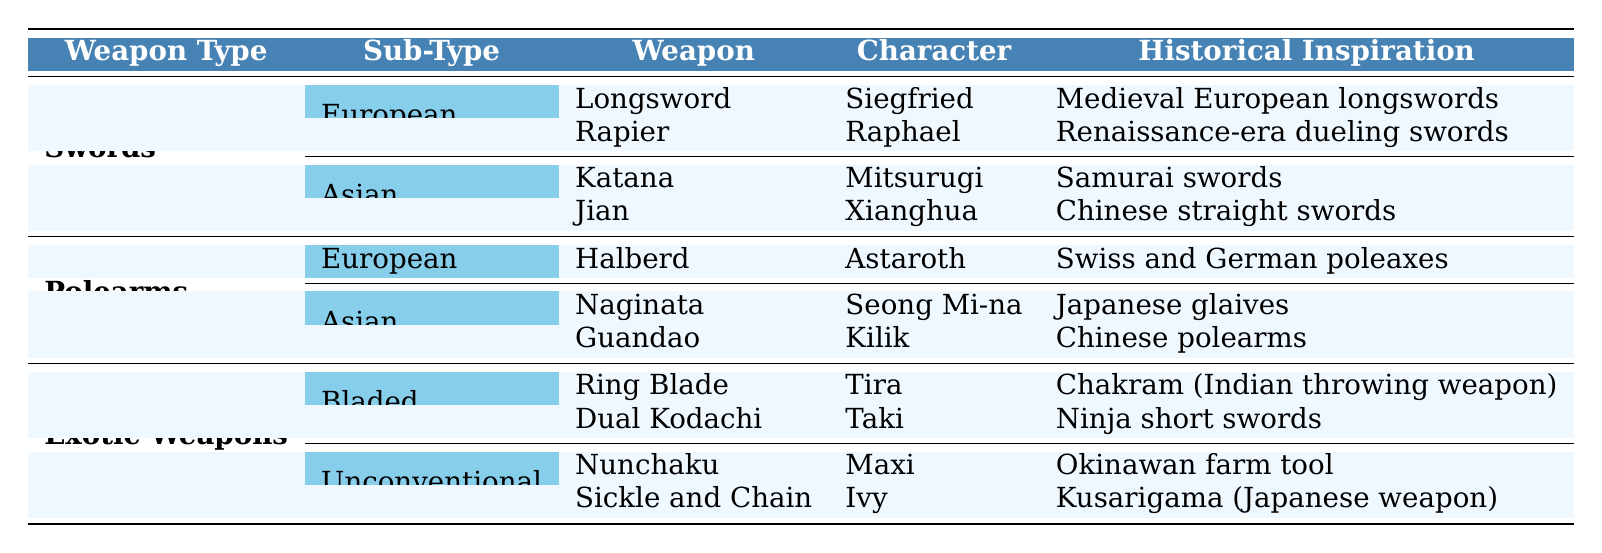What is the historical inspiration for the weapon used by Siegfried? By looking at the row that includes Siegfried, we can see that his weapon is the Longsword, and the historical inspiration listed for it is "Medieval European longswords."
Answer: Medieval European longswords How many different weapon types are represented in the table? The table lists three weapon types: Swords, Polearms, and Exotic Weapons. So, we count them up to get a total of three.
Answer: 3 Which weapon character is associated with the Guandao? By looking at the row corresponding to the Guandao, we find that the associated character is Kilik.
Answer: Kilik Are there any Asian weapons inspired by Chinese martial culture? Yes, the Jian and Guandao are both weapons in the Asian category that have direct historical inspirations from Chinese martial culture.
Answer: Yes Which character uses the Nunchaku, and what is its historical inspiration? From the table, we see that Maxi uses the Nunchaku, and its historical inspiration is an Okinawan farm tool.
Answer: Maxi, Okinawan farm tool What is the relationship between the character Taki and the weapon type "Exotic Weapons"? Taki uses the Dual Kodachi, which is classified under the "Exotic Weapons" category in the table. This shows that she is associated with an unconventional type of weapon.
Answer: Dual Kodachi Identify the weapon type with the most characters listed in the table. Evaluating the number of characters associated with each weapon type, Swords has four characters (Siegfried, Raphael, Mitsurugi, Xianghua), whereas Polearms has three (Astaroth, Seong Mi-na, Kilik), and Exotic Weapons has four (Tira, Taki, Maxi, Ivy). Hence, both Swords and Exotic Weapons tie for the most characters.
Answer: Swords and Exotic Weapons Which weapon is influenced by Japanese glaives and who wields it? Referring to the table, the weapon influenced by Japanese glaives is the Naginata, and it is wielded by Seong Mi-na.
Answer: Naginata, Seong Mi-na What is the difference in the number of characters between European and Asian weapons? Counting the characters, European weapons have 4 (Siegfried, Raphael, Astaroth) and Asian weapons have 4 (Mitsurugi, Xianghua, Seong Mi-na, Kilik). Therefore, the difference is 0, as both have the same number of characters.
Answer: 0 Which two characters share the same weapon origin? Looking at the table, both Kilik (Guandao) and Xianghua (Jian) share the origin "China."
Answer: Kilik and Xianghua Is there any weapon that has its historical inspiration listed as an Indian weapon? Yes, the Ring Blade used by Tira is inspired by the Chakram, which is an Indian throwing weapon.
Answer: Yes 